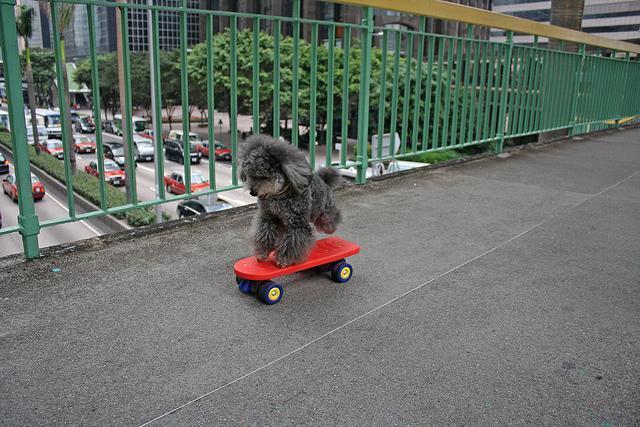How many zebra are in this scene?
Give a very brief answer. 0. 